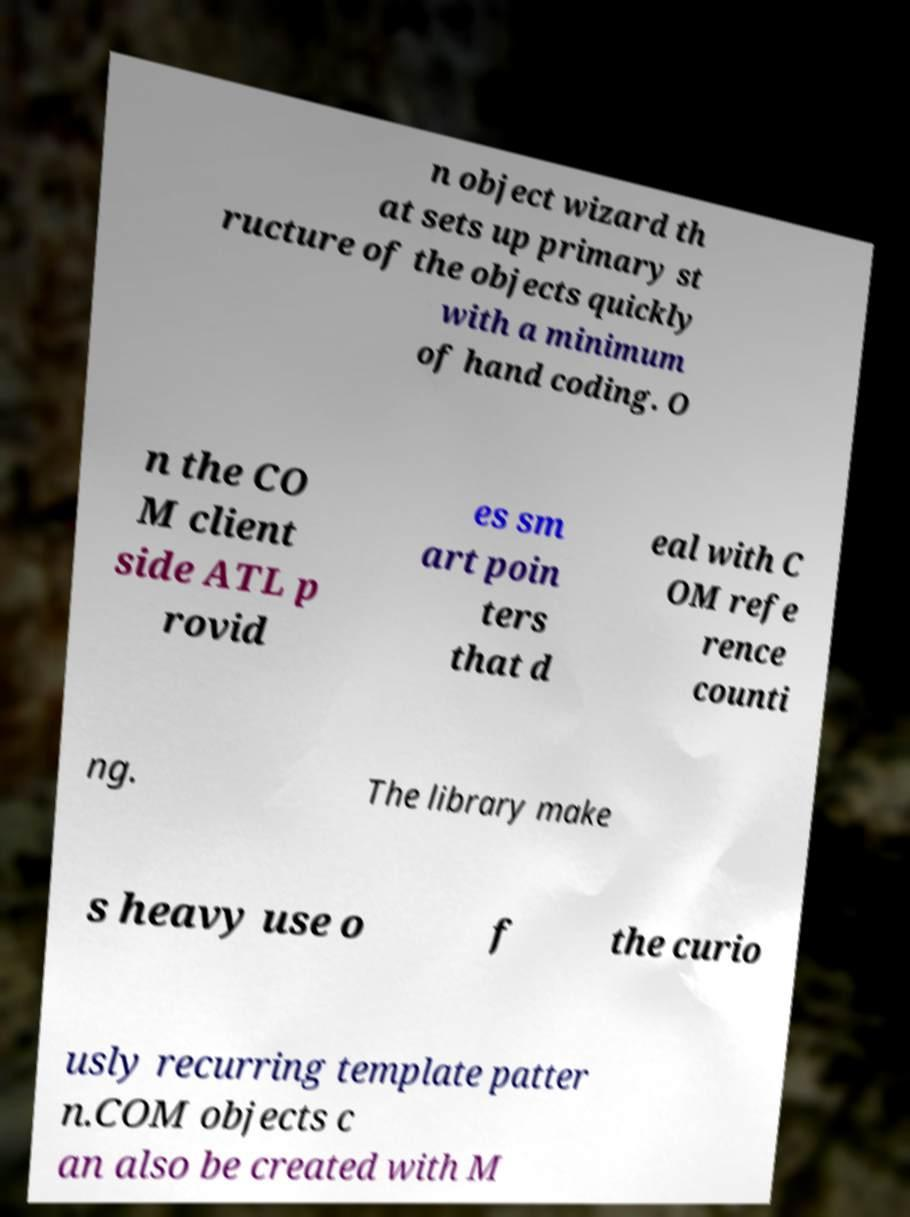There's text embedded in this image that I need extracted. Can you transcribe it verbatim? n object wizard th at sets up primary st ructure of the objects quickly with a minimum of hand coding. O n the CO M client side ATL p rovid es sm art poin ters that d eal with C OM refe rence counti ng. The library make s heavy use o f the curio usly recurring template patter n.COM objects c an also be created with M 